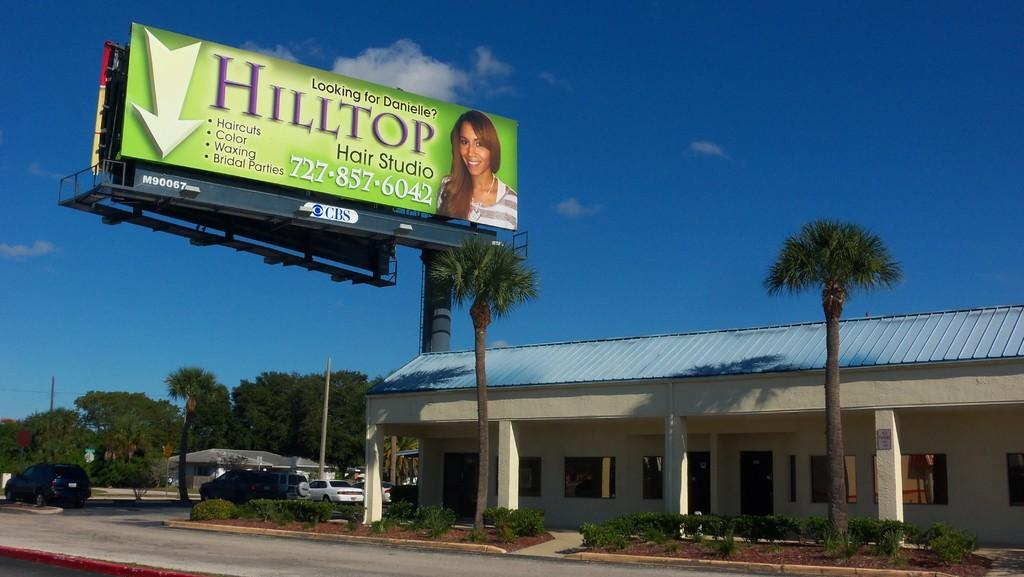<image>
Give a short and clear explanation of the subsequent image. a billboard that says Hilltop on the front 